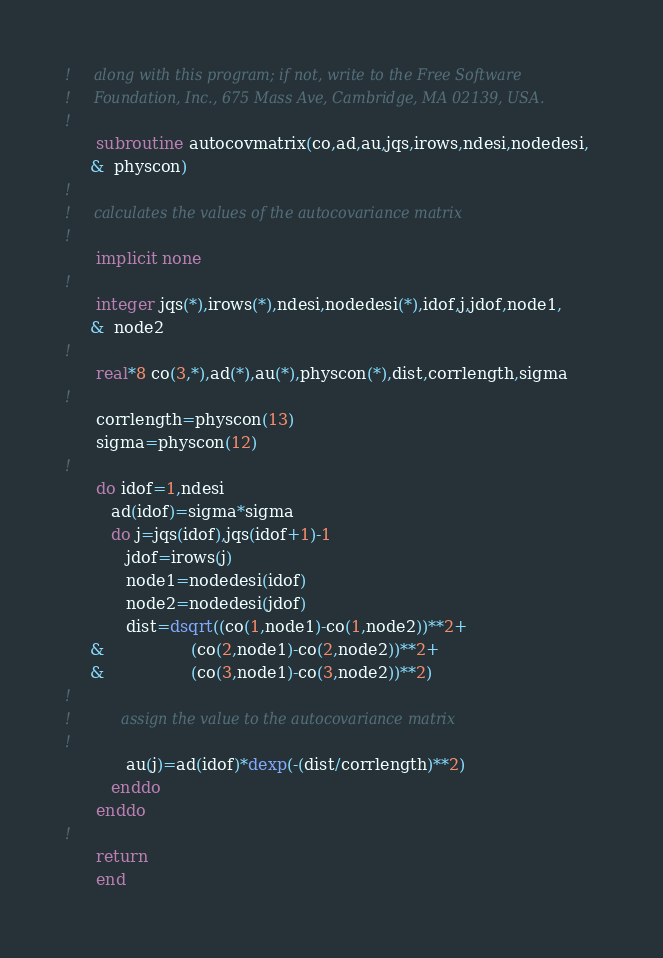Convert code to text. <code><loc_0><loc_0><loc_500><loc_500><_FORTRAN_>!     along with this program; if not, write to the Free Software
!     Foundation, Inc., 675 Mass Ave, Cambridge, MA 02139, USA.
!
      subroutine autocovmatrix(co,ad,au,jqs,irows,ndesi,nodedesi,
     &  physcon)         
!
!     calculates the values of the autocovariance matrix
!
      implicit none
!
      integer jqs(*),irows(*),ndesi,nodedesi(*),idof,j,jdof,node1,
     &  node2
!
      real*8 co(3,*),ad(*),au(*),physcon(*),dist,corrlength,sigma
!
      corrlength=physcon(13)
      sigma=physcon(12)
!
      do idof=1,ndesi
         ad(idof)=sigma*sigma
         do j=jqs(idof),jqs(idof+1)-1
            jdof=irows(j)
            node1=nodedesi(idof)
            node2=nodedesi(jdof)
            dist=dsqrt((co(1,node1)-co(1,node2))**2+
     &                 (co(2,node1)-co(2,node2))**2+
     &                 (co(3,node1)-co(3,node2))**2)
!
!           assign the value to the autocovariance matrix
!
            au(j)=ad(idof)*dexp(-(dist/corrlength)**2)
         enddo
      enddo
!
      return        
      end




</code> 